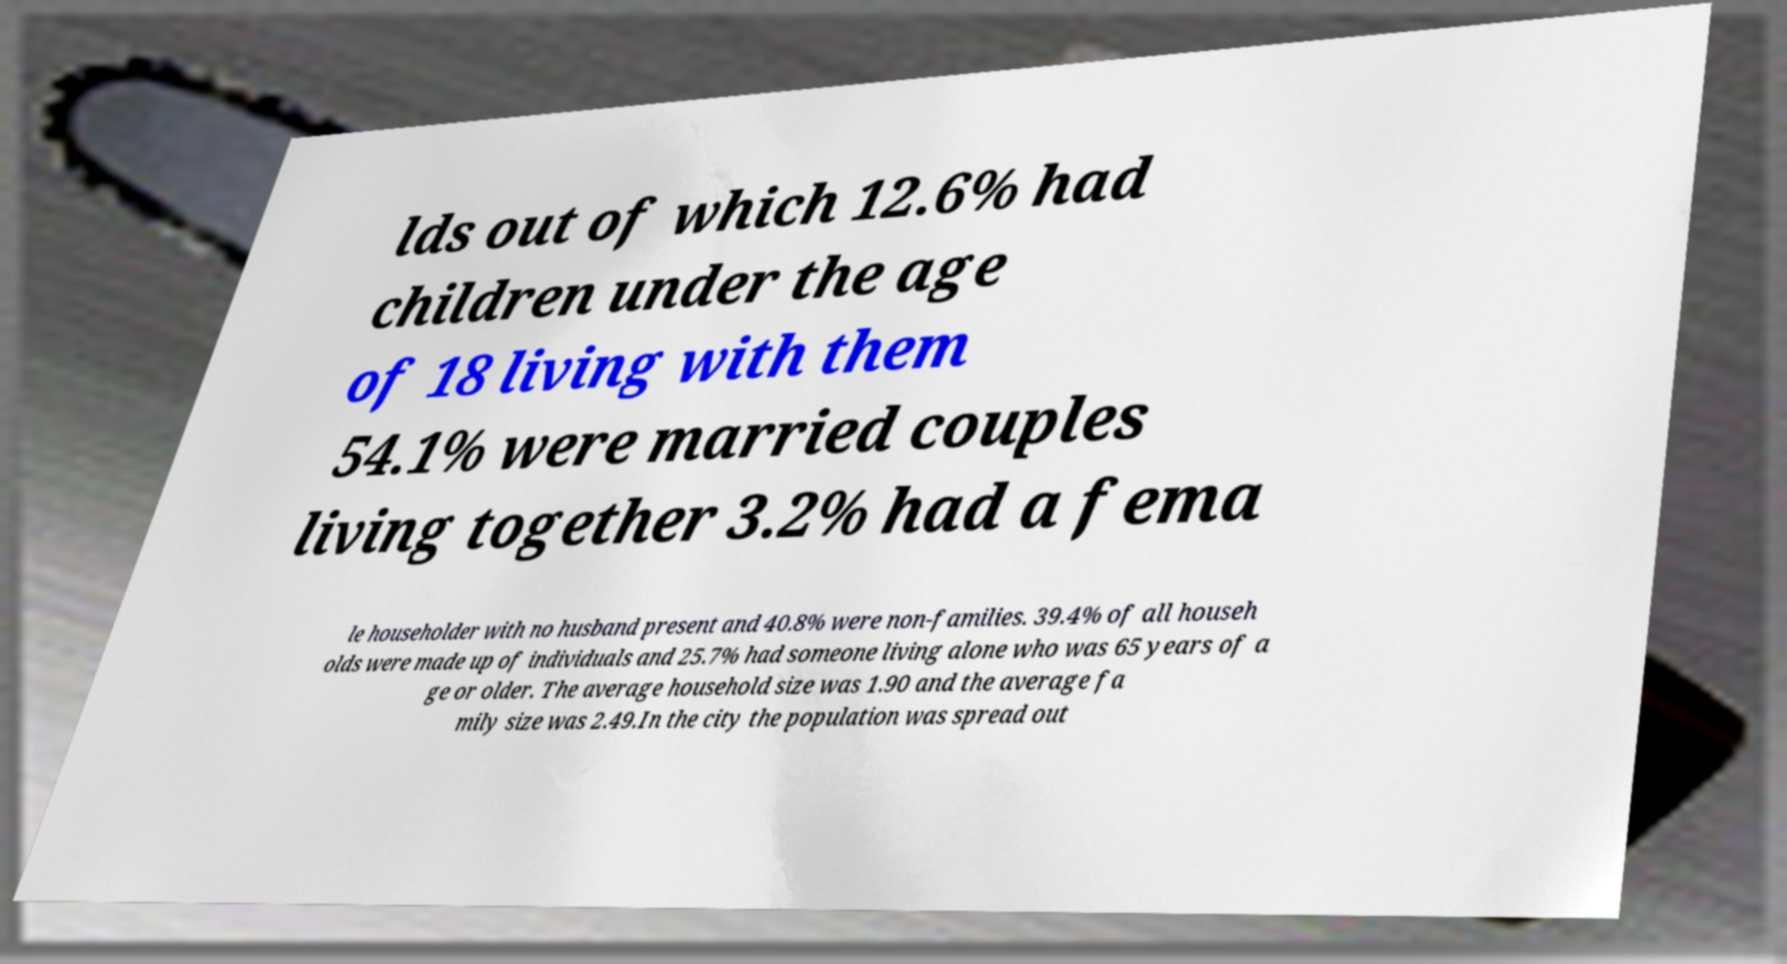Can you accurately transcribe the text from the provided image for me? lds out of which 12.6% had children under the age of 18 living with them 54.1% were married couples living together 3.2% had a fema le householder with no husband present and 40.8% were non-families. 39.4% of all househ olds were made up of individuals and 25.7% had someone living alone who was 65 years of a ge or older. The average household size was 1.90 and the average fa mily size was 2.49.In the city the population was spread out 